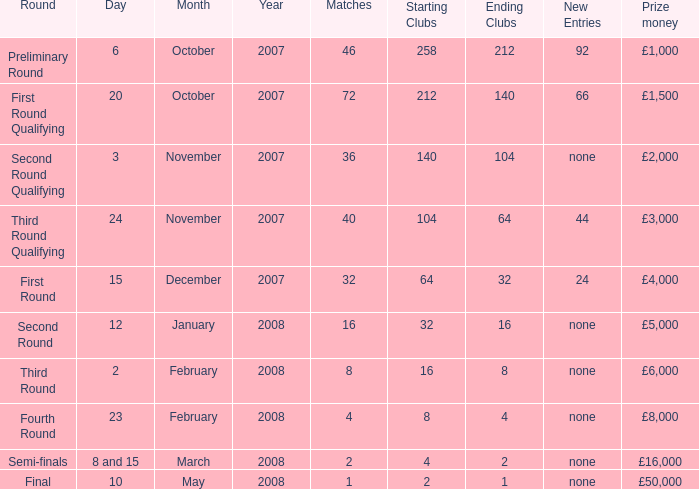What is the typical value for contests with a prize fund of £3,000? 40.0. 